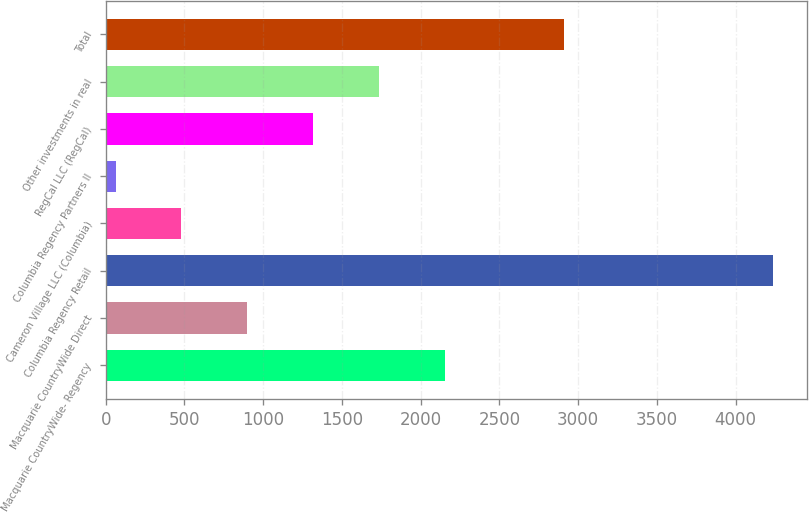Convert chart to OTSL. <chart><loc_0><loc_0><loc_500><loc_500><bar_chart><fcel>Macquarie CountryWide- Regency<fcel>Macquarie CountryWide Direct<fcel>Columbia Regency Retail<fcel>Cameron Village LLC (Columbia)<fcel>Columbia Regency Partners II<fcel>RegCal LLC (RegCal)<fcel>Other investments in real<fcel>Total<nl><fcel>2152<fcel>898.6<fcel>4241<fcel>480.8<fcel>63<fcel>1316.4<fcel>1734.2<fcel>2908<nl></chart> 